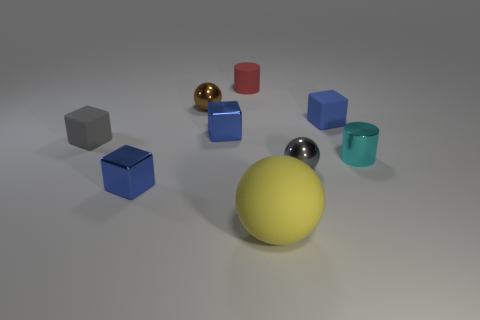Subtract all blue blocks. How many were subtracted if there are1blue blocks left? 2 Subtract all gray cylinders. How many blue blocks are left? 3 Subtract all cyan blocks. Subtract all purple cylinders. How many blocks are left? 4 Subtract all spheres. How many objects are left? 6 Subtract all gray spheres. Subtract all big things. How many objects are left? 7 Add 2 tiny blue cubes. How many tiny blue cubes are left? 5 Add 9 big brown matte things. How many big brown matte things exist? 9 Subtract 0 green blocks. How many objects are left? 9 